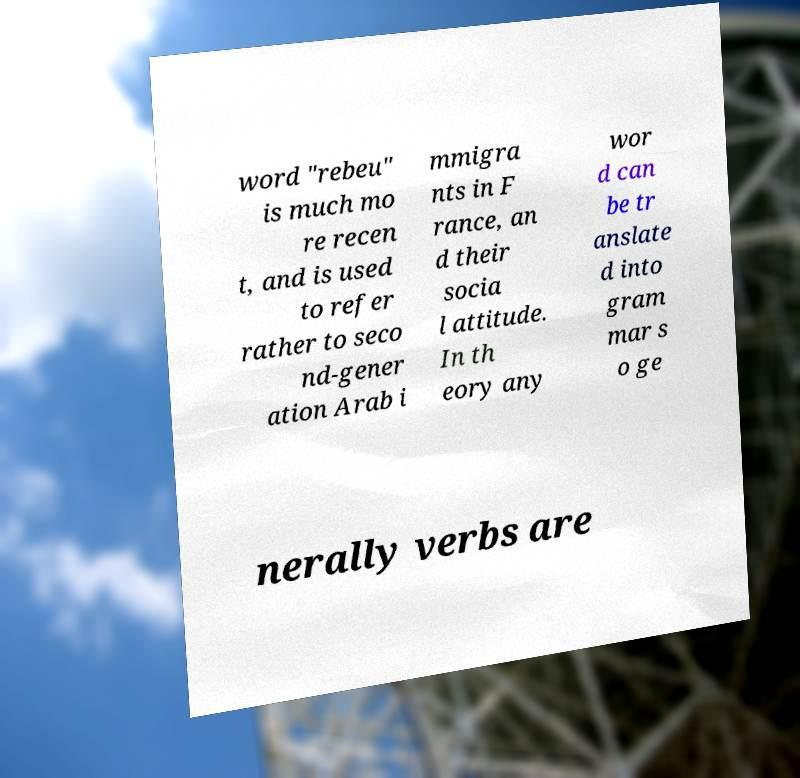Please read and relay the text visible in this image. What does it say? word "rebeu" is much mo re recen t, and is used to refer rather to seco nd-gener ation Arab i mmigra nts in F rance, an d their socia l attitude. In th eory any wor d can be tr anslate d into gram mar s o ge nerally verbs are 